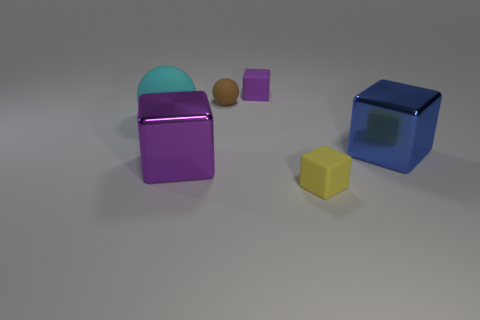There is a matte block that is behind the large purple cube; is it the same color as the large matte ball?
Keep it short and to the point. No. There is a matte sphere behind the big cyan matte sphere; how many matte cubes are behind it?
Make the answer very short. 1. What is the color of the other matte cube that is the same size as the purple rubber cube?
Give a very brief answer. Yellow. What material is the purple block behind the purple metal object?
Offer a very short reply. Rubber. There is a tiny thing that is both on the right side of the tiny brown sphere and behind the yellow cube; what material is it?
Provide a short and direct response. Rubber. Is the size of the purple thing behind the blue thing the same as the large purple block?
Offer a very short reply. No. The large purple metallic object has what shape?
Your answer should be compact. Cube. What number of other rubber things have the same shape as the small purple object?
Offer a terse response. 1. What number of objects are behind the purple shiny block and left of the tiny brown matte thing?
Provide a short and direct response. 1. The large sphere has what color?
Keep it short and to the point. Cyan. 